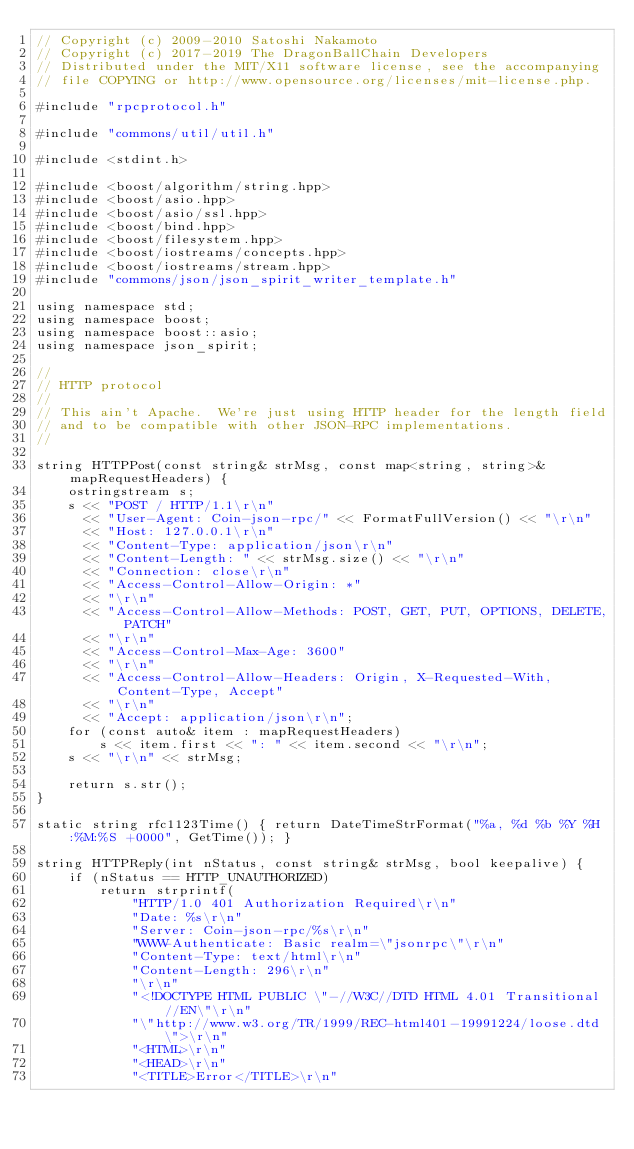Convert code to text. <code><loc_0><loc_0><loc_500><loc_500><_C++_>// Copyright (c) 2009-2010 Satoshi Nakamoto
// Copyright (c) 2017-2019 The DragonBallChain Developers
// Distributed under the MIT/X11 software license, see the accompanying
// file COPYING or http://www.opensource.org/licenses/mit-license.php.

#include "rpcprotocol.h"

#include "commons/util/util.h"

#include <stdint.h>

#include <boost/algorithm/string.hpp>
#include <boost/asio.hpp>
#include <boost/asio/ssl.hpp>
#include <boost/bind.hpp>
#include <boost/filesystem.hpp>
#include <boost/iostreams/concepts.hpp>
#include <boost/iostreams/stream.hpp>
#include "commons/json/json_spirit_writer_template.h"

using namespace std;
using namespace boost;
using namespace boost::asio;
using namespace json_spirit;

//
// HTTP protocol
//
// This ain't Apache.  We're just using HTTP header for the length field
// and to be compatible with other JSON-RPC implementations.
//

string HTTPPost(const string& strMsg, const map<string, string>& mapRequestHeaders) {
    ostringstream s;
    s << "POST / HTTP/1.1\r\n"
      << "User-Agent: Coin-json-rpc/" << FormatFullVersion() << "\r\n"
      << "Host: 127.0.0.1\r\n"
      << "Content-Type: application/json\r\n"
      << "Content-Length: " << strMsg.size() << "\r\n"
      << "Connection: close\r\n"
      << "Access-Control-Allow-Origin: *"
      << "\r\n"
      << "Access-Control-Allow-Methods: POST, GET, PUT, OPTIONS, DELETE, PATCH"
      << "\r\n"
      << "Access-Control-Max-Age: 3600"
      << "\r\n"
      << "Access-Control-Allow-Headers: Origin, X-Requested-With, Content-Type, Accept"
      << "\r\n"
      << "Accept: application/json\r\n";
    for (const auto& item : mapRequestHeaders)
        s << item.first << ": " << item.second << "\r\n";
    s << "\r\n" << strMsg;

    return s.str();
}

static string rfc1123Time() { return DateTimeStrFormat("%a, %d %b %Y %H:%M:%S +0000", GetTime()); }

string HTTPReply(int nStatus, const string& strMsg, bool keepalive) {
    if (nStatus == HTTP_UNAUTHORIZED)
        return strprintf(
            "HTTP/1.0 401 Authorization Required\r\n"
            "Date: %s\r\n"
            "Server: Coin-json-rpc/%s\r\n"
            "WWW-Authenticate: Basic realm=\"jsonrpc\"\r\n"
            "Content-Type: text/html\r\n"
            "Content-Length: 296\r\n"
            "\r\n"
            "<!DOCTYPE HTML PUBLIC \"-//W3C//DTD HTML 4.01 Transitional//EN\"\r\n"
            "\"http://www.w3.org/TR/1999/REC-html401-19991224/loose.dtd\">\r\n"
            "<HTML>\r\n"
            "<HEAD>\r\n"
            "<TITLE>Error</TITLE>\r\n"</code> 